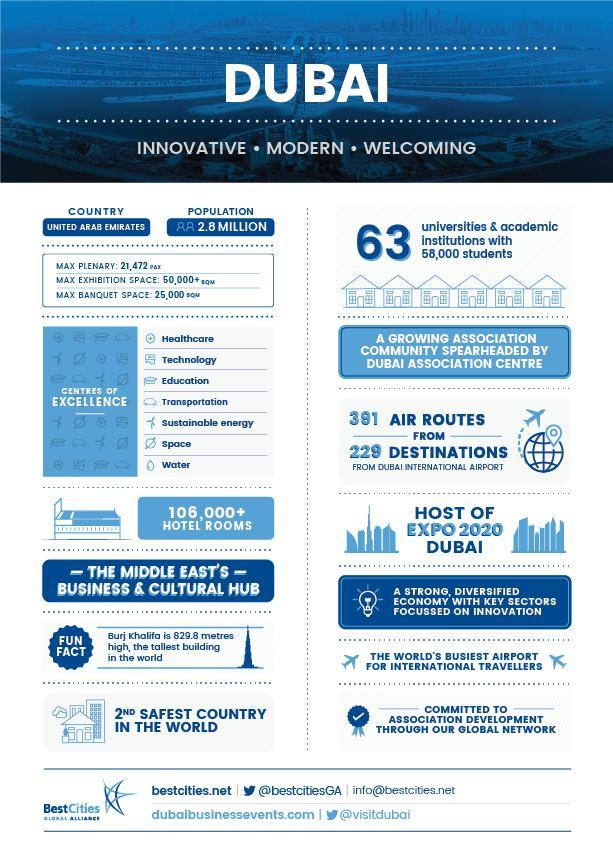How many centres of Excellence are there in Dubai?
Answer the question with a short phrase. 7 